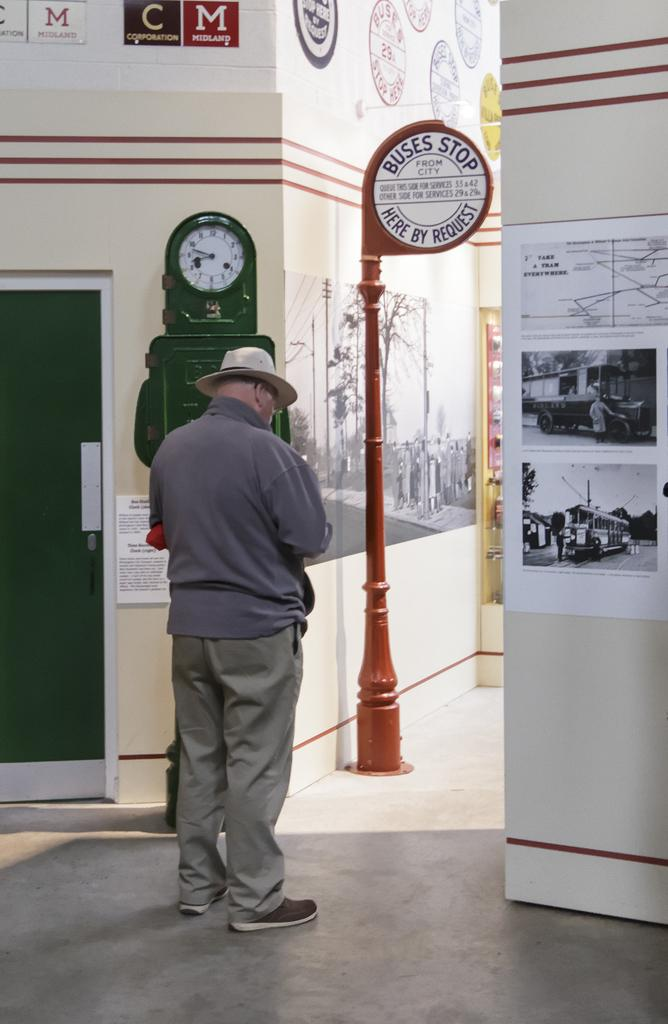<image>
Share a concise interpretation of the image provided. A man stands near a BUSES STOP HERE BY REQUEST sign 